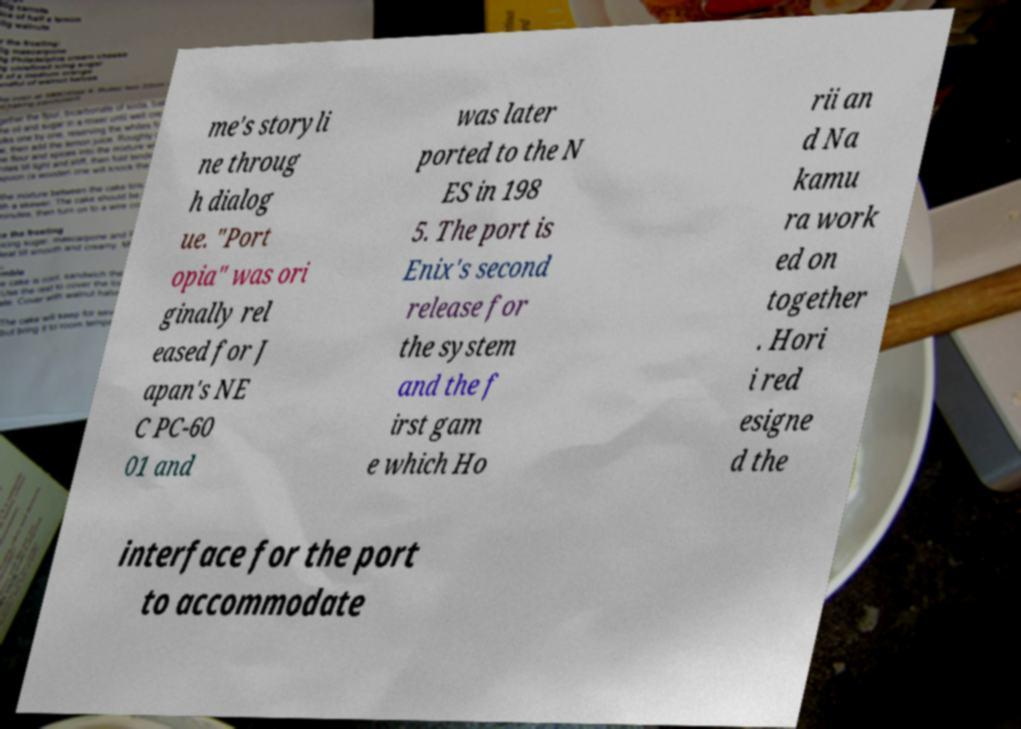Could you extract and type out the text from this image? me's storyli ne throug h dialog ue. "Port opia" was ori ginally rel eased for J apan's NE C PC-60 01 and was later ported to the N ES in 198 5. The port is Enix's second release for the system and the f irst gam e which Ho rii an d Na kamu ra work ed on together . Hori i red esigne d the interface for the port to accommodate 